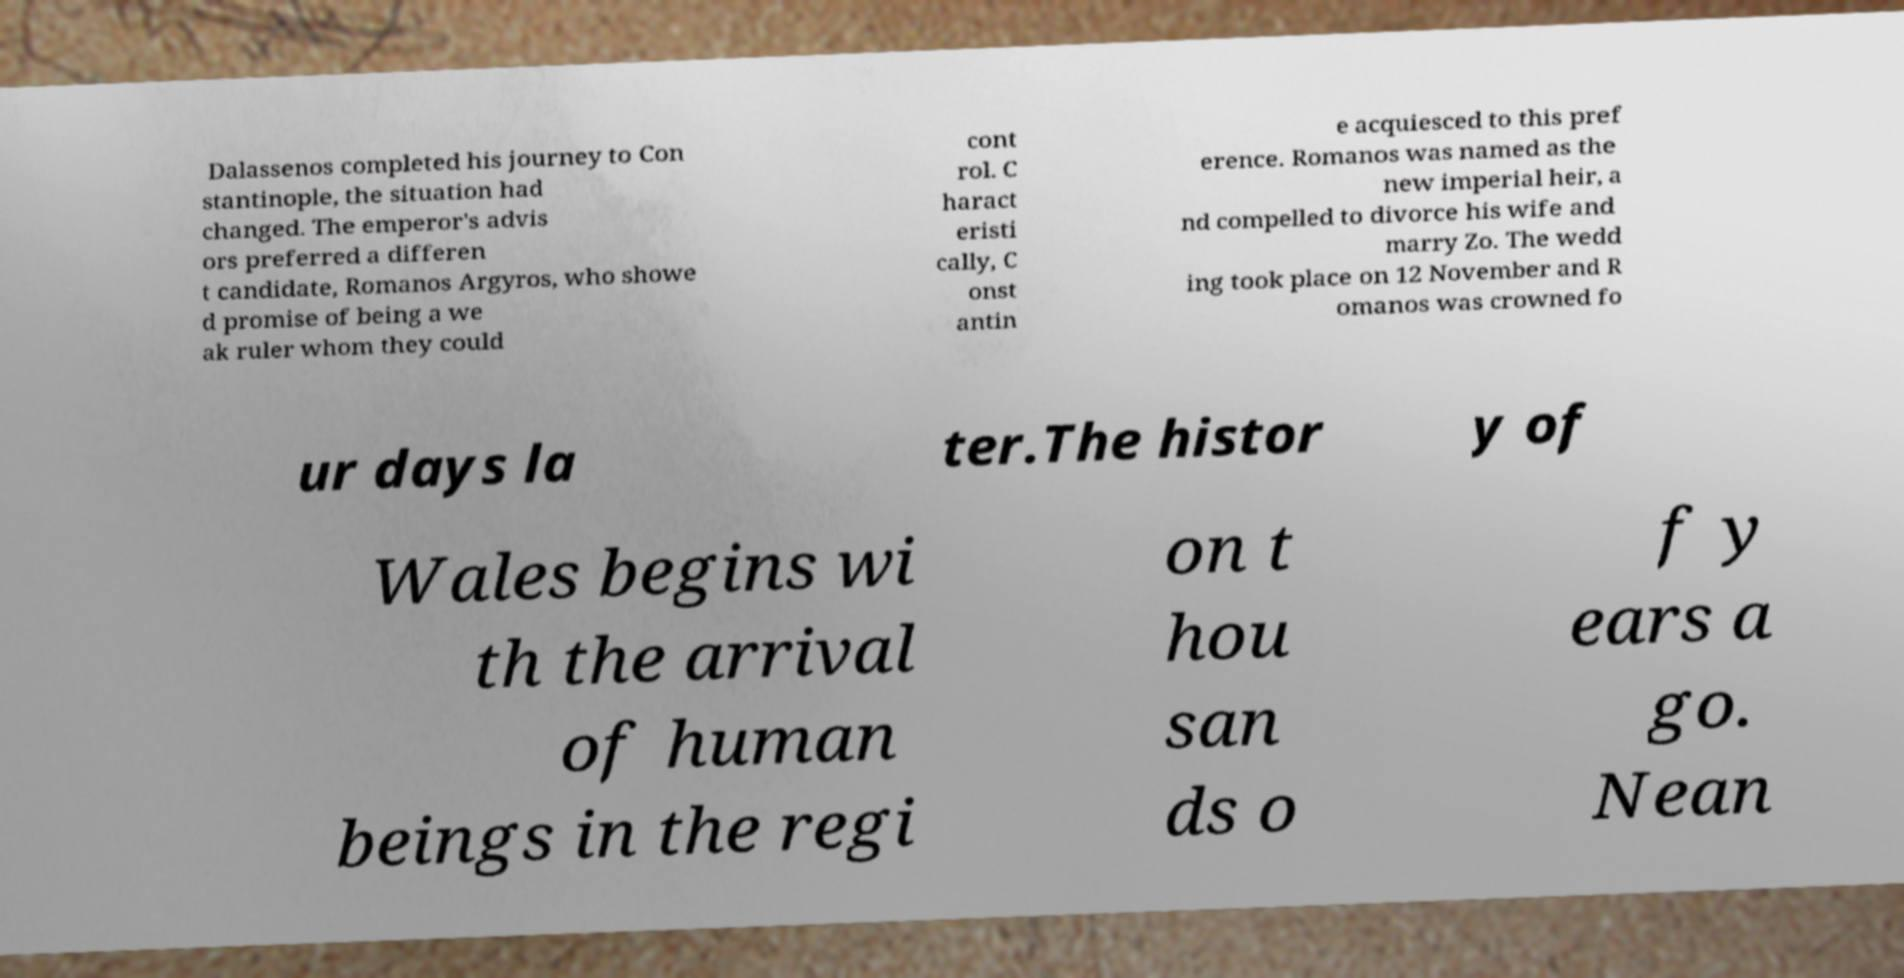Could you assist in decoding the text presented in this image and type it out clearly? Dalassenos completed his journey to Con stantinople, the situation had changed. The emperor's advis ors preferred a differen t candidate, Romanos Argyros, who showe d promise of being a we ak ruler whom they could cont rol. C haract eristi cally, C onst antin e acquiesced to this pref erence. Romanos was named as the new imperial heir, a nd compelled to divorce his wife and marry Zo. The wedd ing took place on 12 November and R omanos was crowned fo ur days la ter.The histor y of Wales begins wi th the arrival of human beings in the regi on t hou san ds o f y ears a go. Nean 